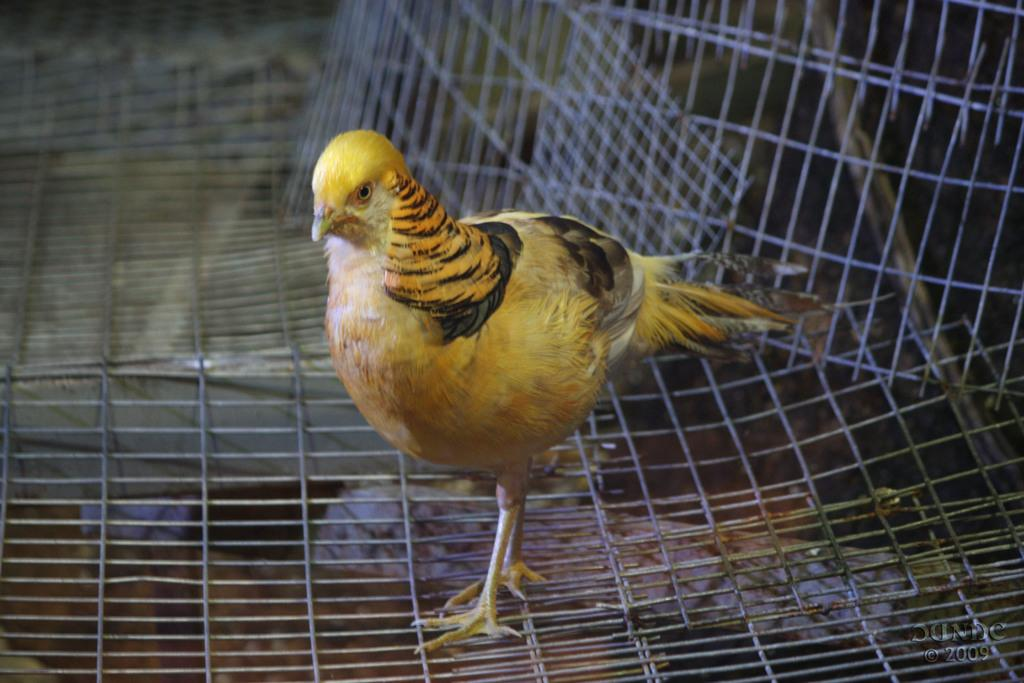What type of animal is in the image? There is a yellow hen in the image. What is the hen standing on? The hen is standing on steel fencing. What can be seen at the bottom of the image? The floor is visible at the bottom of the image. Is there any text or marking in the image? Yes, there is a watermark in the bottom right corner of the image. Where is the cactus located in the image? There is no cactus present in the image. What type of frame surrounds the image? The image does not show a frame; it is a standalone image. 